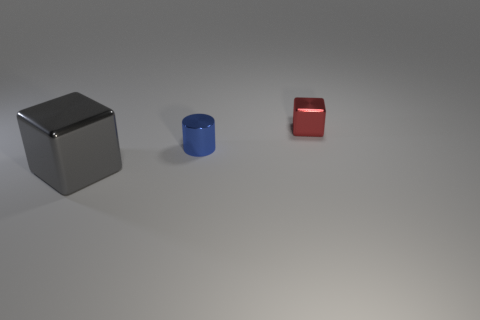Subtract all gray cubes. How many cubes are left? 1 Subtract all brown balls. How many gray cubes are left? 1 Subtract all large gray metal things. Subtract all cylinders. How many objects are left? 1 Add 1 large metallic things. How many large metallic things are left? 2 Add 2 red metallic cubes. How many red metallic cubes exist? 3 Add 2 yellow cubes. How many objects exist? 5 Subtract 0 yellow cylinders. How many objects are left? 3 Subtract all cylinders. How many objects are left? 2 Subtract 1 cubes. How many cubes are left? 1 Subtract all yellow cubes. Subtract all green spheres. How many cubes are left? 2 